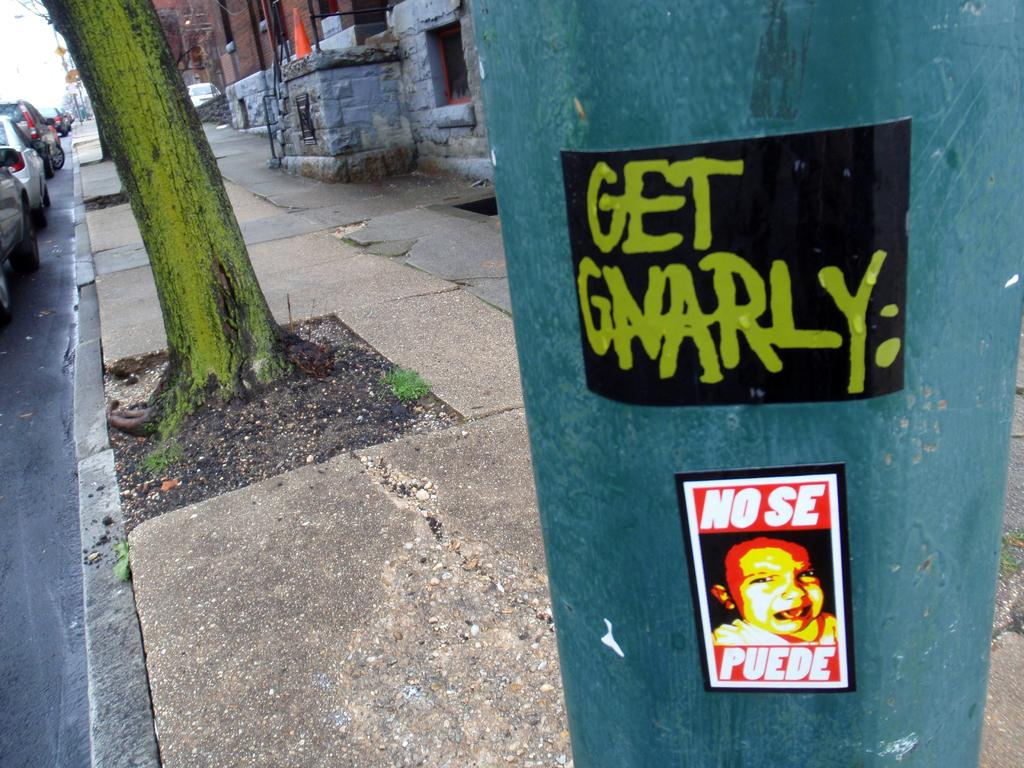<image>
Describe the image concisely. A sticker that says No Se Puede has been added to a blue pillar. 